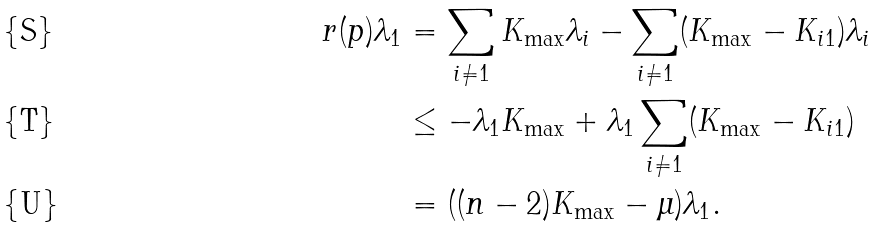<formula> <loc_0><loc_0><loc_500><loc_500>r ( p ) \lambda _ { 1 } & = \sum _ { i \neq 1 } K _ { \max } \lambda _ { i } - \sum _ { i \neq 1 } ( K _ { \max } - K _ { i 1 } ) \lambda _ { i } \\ & \leq - \lambda _ { 1 } K _ { \max } + \lambda _ { 1 } \sum _ { i \neq 1 } ( K _ { \max } - K _ { i 1 } ) \\ & = ( ( n - 2 ) K _ { \max } - \mu ) \lambda _ { 1 } .</formula> 